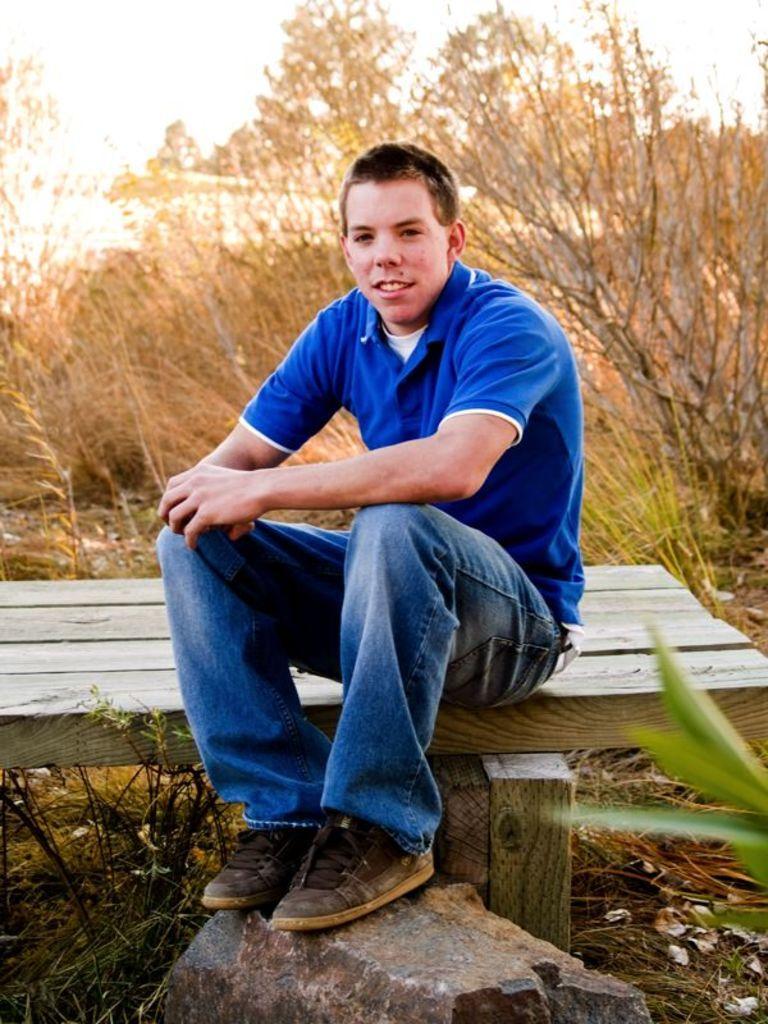Can you describe this image briefly? In this image we can see a man sitting on the bench by placing his feet on the stone. In the background there are trees and sky. 